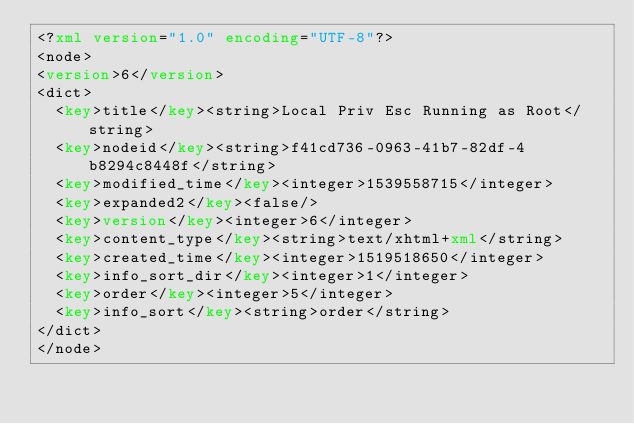<code> <loc_0><loc_0><loc_500><loc_500><_XML_><?xml version="1.0" encoding="UTF-8"?>
<node>
<version>6</version>
<dict>
  <key>title</key><string>Local Priv Esc Running as Root</string>
  <key>nodeid</key><string>f41cd736-0963-41b7-82df-4b8294c8448f</string>
  <key>modified_time</key><integer>1539558715</integer>
  <key>expanded2</key><false/>
  <key>version</key><integer>6</integer>
  <key>content_type</key><string>text/xhtml+xml</string>
  <key>created_time</key><integer>1519518650</integer>
  <key>info_sort_dir</key><integer>1</integer>
  <key>order</key><integer>5</integer>
  <key>info_sort</key><string>order</string>
</dict>
</node>
</code> 